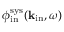Convert formula to latex. <formula><loc_0><loc_0><loc_500><loc_500>\phi _ { i n } ^ { s y s } ( { k } _ { i n } , \omega )</formula> 